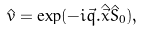Convert formula to latex. <formula><loc_0><loc_0><loc_500><loc_500>\hat { v } = \exp ( - i \vec { q } . \hat { \vec { x } } \hat { S } _ { 0 } ) ,</formula> 